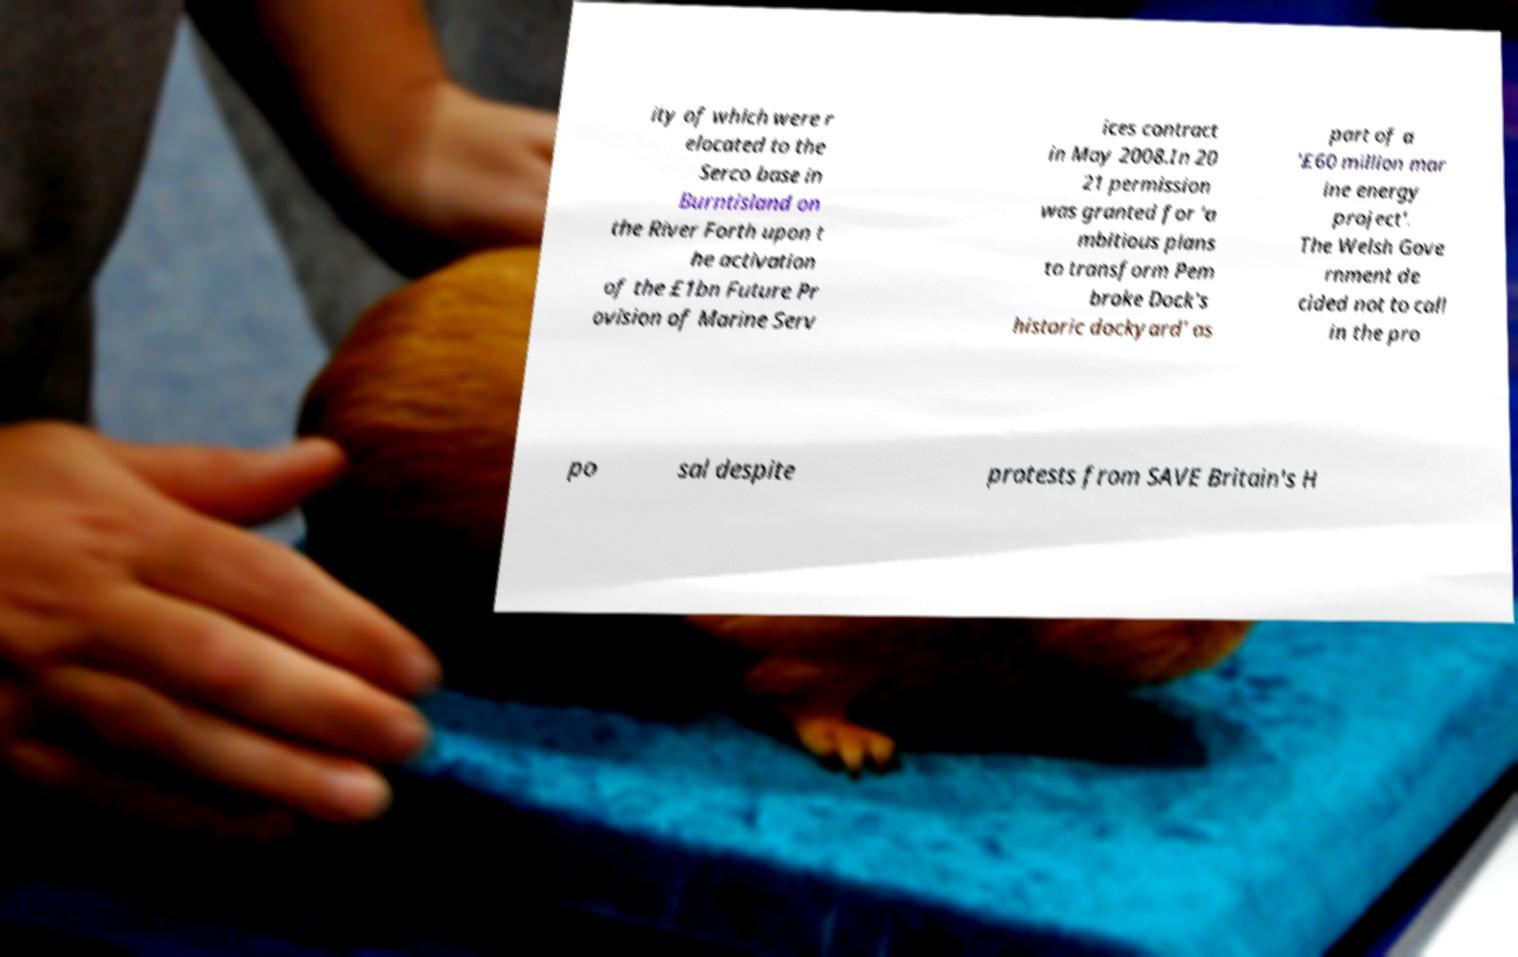I need the written content from this picture converted into text. Can you do that? ity of which were r elocated to the Serco base in Burntisland on the River Forth upon t he activation of the £1bn Future Pr ovision of Marine Serv ices contract in May 2008.In 20 21 permission was granted for 'a mbitious plans to transform Pem broke Dock's historic dockyard' as part of a '£60 million mar ine energy project'. The Welsh Gove rnment de cided not to call in the pro po sal despite protests from SAVE Britain's H 